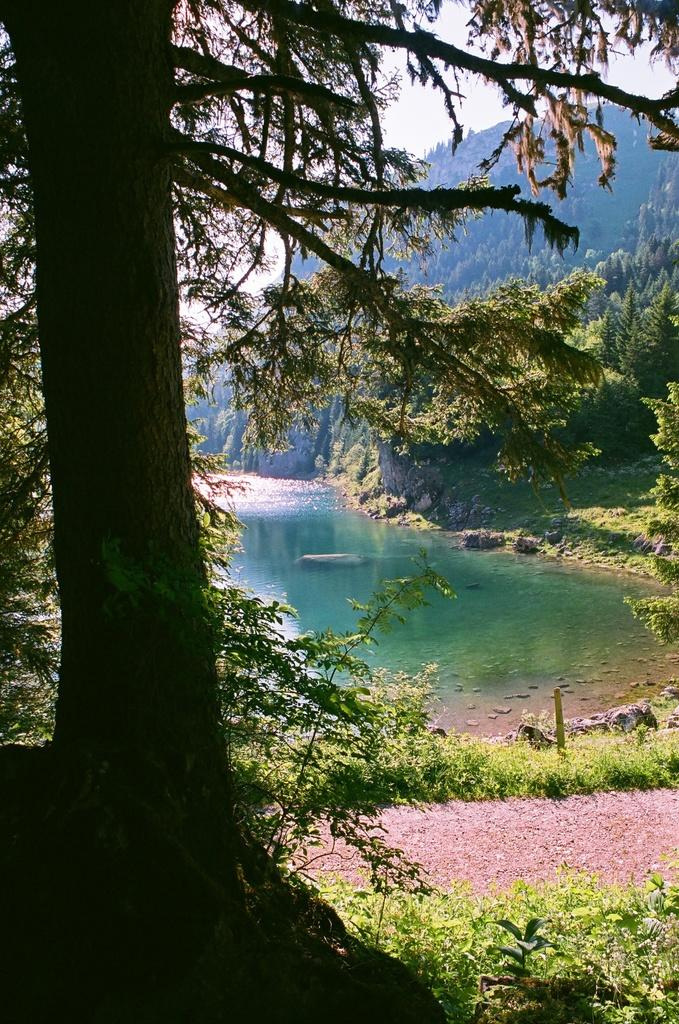What type of vegetation can be seen in the image? There are plants and trees visible in the image. What natural element is present in the image? There is water visible in the image. Where is the kettle located in the image? There is no kettle present in the image. What type of plants can be seen playing volleyball in the image? There are no plants or volleyball in the image. 